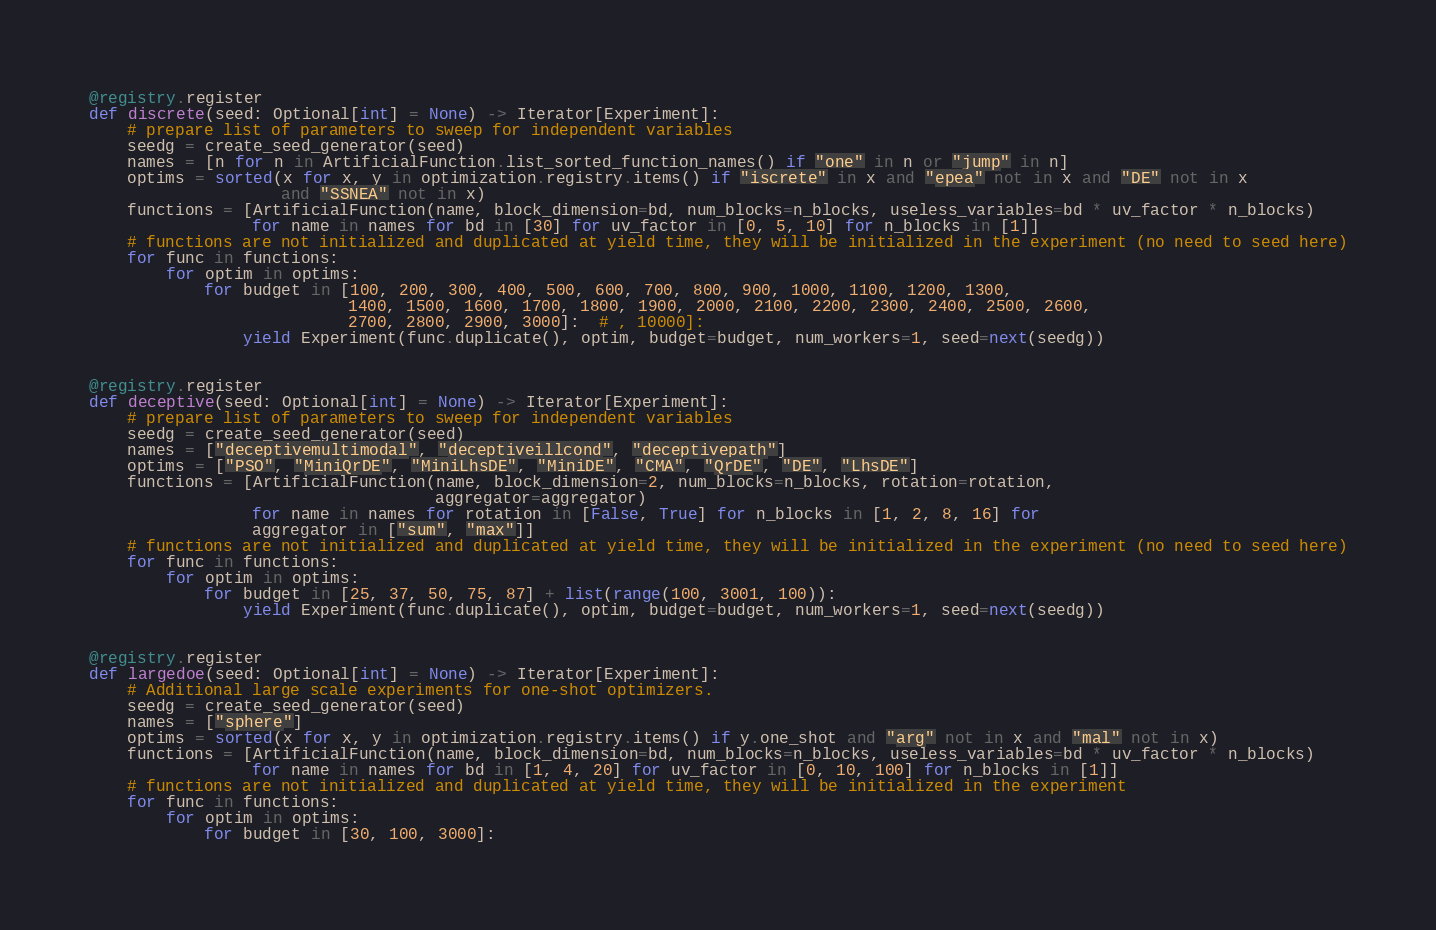Convert code to text. <code><loc_0><loc_0><loc_500><loc_500><_Python_>

@registry.register
def discrete(seed: Optional[int] = None) -> Iterator[Experiment]:
    # prepare list of parameters to sweep for independent variables
    seedg = create_seed_generator(seed)
    names = [n for n in ArtificialFunction.list_sorted_function_names() if "one" in n or "jump" in n]
    optims = sorted(x for x, y in optimization.registry.items() if "iscrete" in x and "epea" not in x and "DE" not in x
                    and "SSNEA" not in x)
    functions = [ArtificialFunction(name, block_dimension=bd, num_blocks=n_blocks, useless_variables=bd * uv_factor * n_blocks)
                 for name in names for bd in [30] for uv_factor in [0, 5, 10] for n_blocks in [1]]
    # functions are not initialized and duplicated at yield time, they will be initialized in the experiment (no need to seed here)
    for func in functions:
        for optim in optims:
            for budget in [100, 200, 300, 400, 500, 600, 700, 800, 900, 1000, 1100, 1200, 1300,
                           1400, 1500, 1600, 1700, 1800, 1900, 2000, 2100, 2200, 2300, 2400, 2500, 2600,
                           2700, 2800, 2900, 3000]:  # , 10000]:
                yield Experiment(func.duplicate(), optim, budget=budget, num_workers=1, seed=next(seedg))


@registry.register
def deceptive(seed: Optional[int] = None) -> Iterator[Experiment]:
    # prepare list of parameters to sweep for independent variables
    seedg = create_seed_generator(seed)
    names = ["deceptivemultimodal", "deceptiveillcond", "deceptivepath"]
    optims = ["PSO", "MiniQrDE", "MiniLhsDE", "MiniDE", "CMA", "QrDE", "DE", "LhsDE"]
    functions = [ArtificialFunction(name, block_dimension=2, num_blocks=n_blocks, rotation=rotation,
                                    aggregator=aggregator)
                 for name in names for rotation in [False, True] for n_blocks in [1, 2, 8, 16] for
                 aggregator in ["sum", "max"]]
    # functions are not initialized and duplicated at yield time, they will be initialized in the experiment (no need to seed here)
    for func in functions:
        for optim in optims:
            for budget in [25, 37, 50, 75, 87] + list(range(100, 3001, 100)):
                yield Experiment(func.duplicate(), optim, budget=budget, num_workers=1, seed=next(seedg))


@registry.register
def largedoe(seed: Optional[int] = None) -> Iterator[Experiment]:
    # Additional large scale experiments for one-shot optimizers.
    seedg = create_seed_generator(seed)
    names = ["sphere"]
    optims = sorted(x for x, y in optimization.registry.items() if y.one_shot and "arg" not in x and "mal" not in x)
    functions = [ArtificialFunction(name, block_dimension=bd, num_blocks=n_blocks, useless_variables=bd * uv_factor * n_blocks)
                 for name in names for bd in [1, 4, 20] for uv_factor in [0, 10, 100] for n_blocks in [1]]
    # functions are not initialized and duplicated at yield time, they will be initialized in the experiment
    for func in functions:
        for optim in optims:
            for budget in [30, 100, 3000]:</code> 